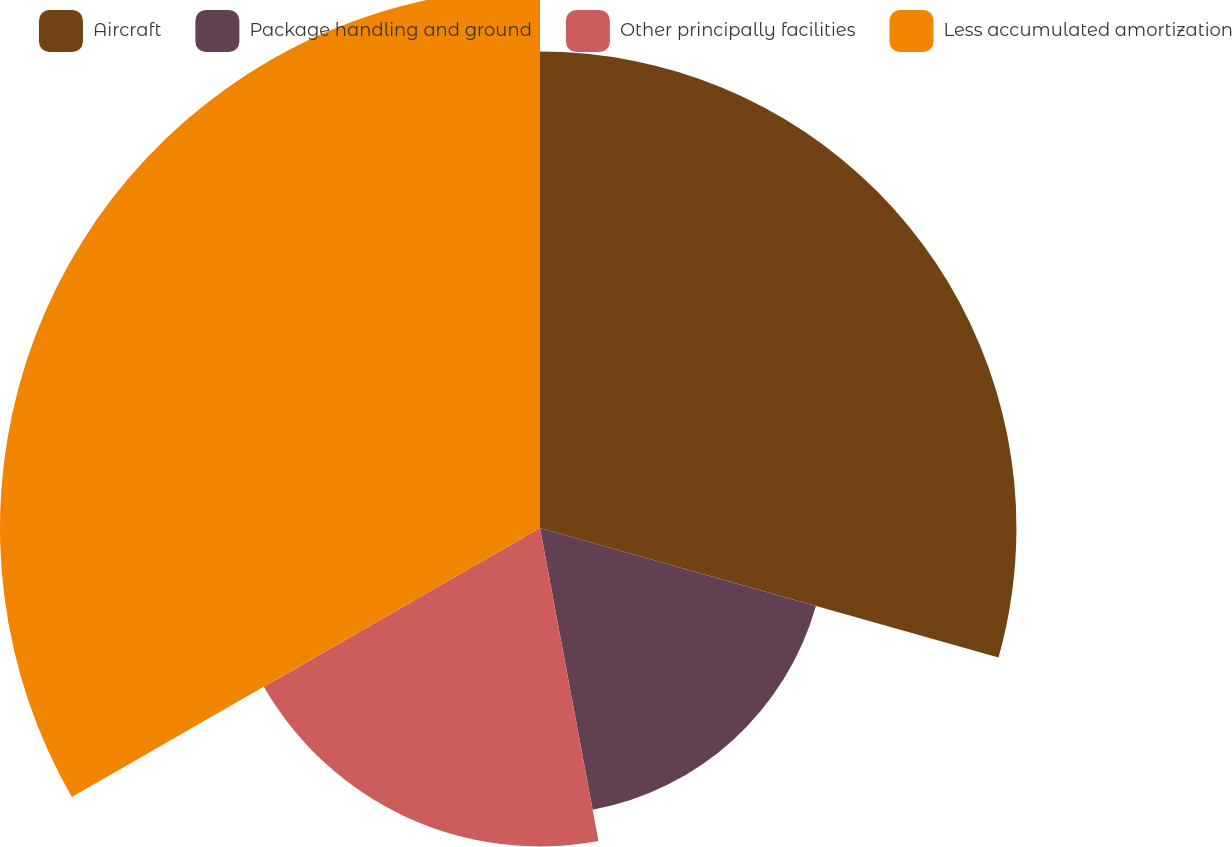<chart> <loc_0><loc_0><loc_500><loc_500><pie_chart><fcel>Aircraft<fcel>Package handling and ground<fcel>Other principally facilities<fcel>Less accumulated amortization<nl><fcel>29.38%<fcel>17.68%<fcel>19.64%<fcel>33.3%<nl></chart> 